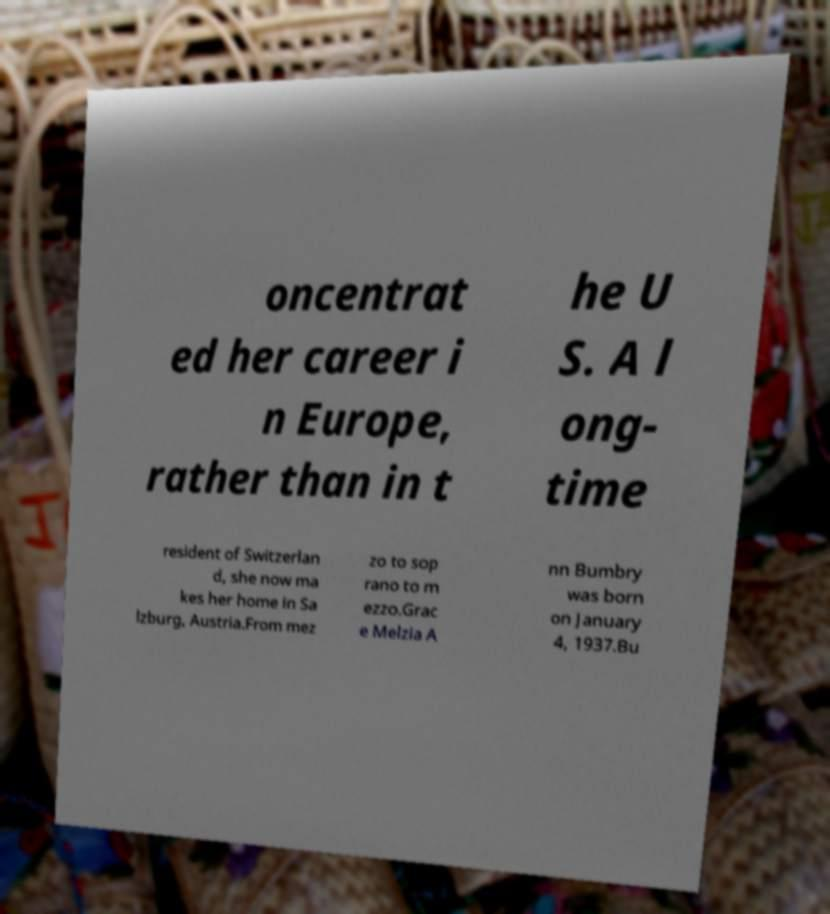I need the written content from this picture converted into text. Can you do that? oncentrat ed her career i n Europe, rather than in t he U S. A l ong- time resident of Switzerlan d, she now ma kes her home in Sa lzburg, Austria.From mez zo to sop rano to m ezzo.Grac e Melzia A nn Bumbry was born on January 4, 1937.Bu 